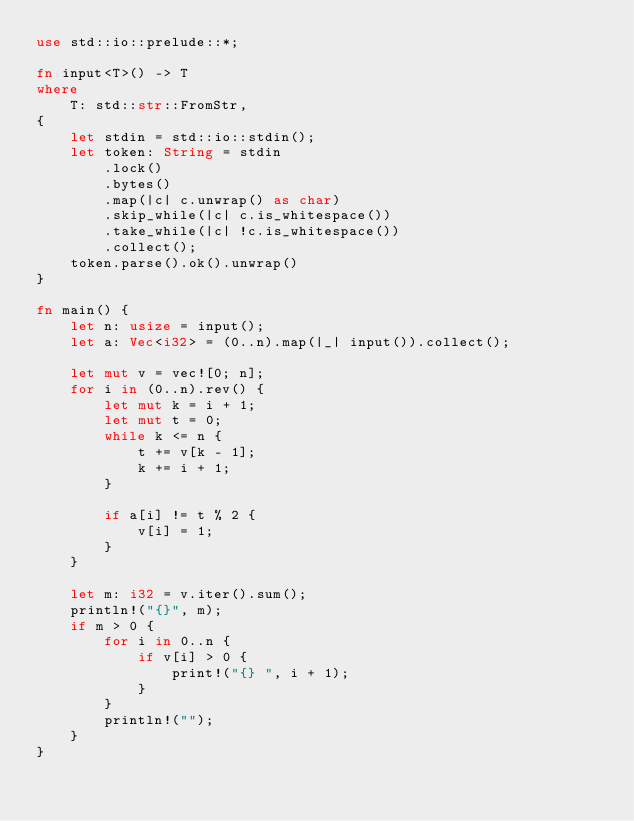<code> <loc_0><loc_0><loc_500><loc_500><_Rust_>use std::io::prelude::*;

fn input<T>() -> T
where
    T: std::str::FromStr,
{
    let stdin = std::io::stdin();
    let token: String = stdin
        .lock()
        .bytes()
        .map(|c| c.unwrap() as char)
        .skip_while(|c| c.is_whitespace())
        .take_while(|c| !c.is_whitespace())
        .collect();
    token.parse().ok().unwrap()
}

fn main() {
    let n: usize = input();
    let a: Vec<i32> = (0..n).map(|_| input()).collect();

    let mut v = vec![0; n];
    for i in (0..n).rev() {
        let mut k = i + 1;
        let mut t = 0;
        while k <= n {
            t += v[k - 1];
            k += i + 1;
        }

        if a[i] != t % 2 {
            v[i] = 1;
        }
    }

    let m: i32 = v.iter().sum();
    println!("{}", m);
    if m > 0 {
        for i in 0..n {
            if v[i] > 0 {
                print!("{} ", i + 1);
            }
        }
        println!("");
    }
}
</code> 